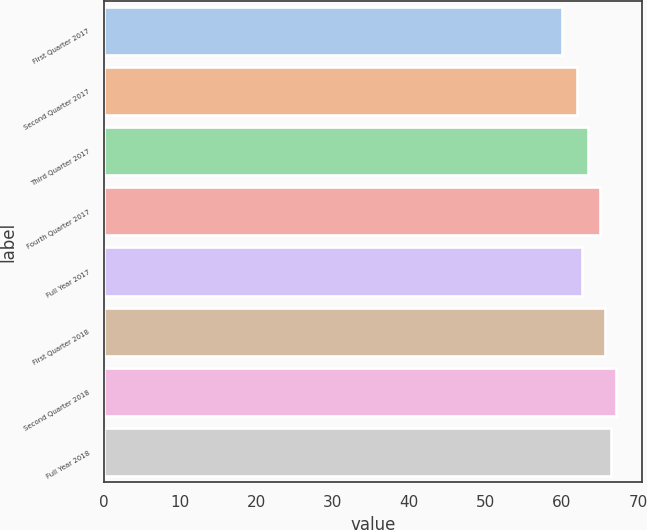Convert chart. <chart><loc_0><loc_0><loc_500><loc_500><bar_chart><fcel>First Quarter 2017<fcel>Second Quarter 2017<fcel>Third Quarter 2017<fcel>Fourth Quarter 2017<fcel>Full Year 2017<fcel>First Quarter 2018<fcel>Second Quarter 2018<fcel>Full Year 2018<nl><fcel>60<fcel>62<fcel>63.4<fcel>65<fcel>62.7<fcel>65.7<fcel>67.1<fcel>66.4<nl></chart> 